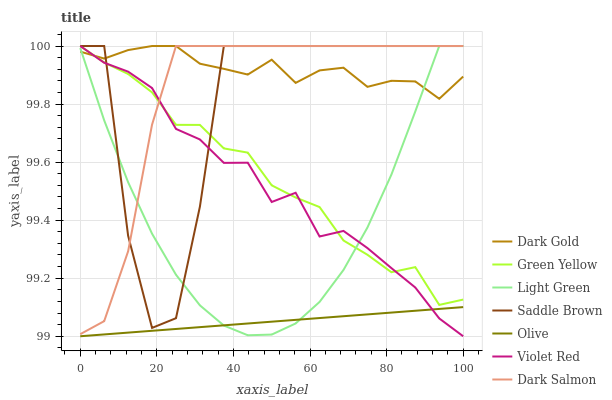Does Olive have the minimum area under the curve?
Answer yes or no. Yes. Does Dark Gold have the maximum area under the curve?
Answer yes or no. Yes. Does Dark Salmon have the minimum area under the curve?
Answer yes or no. No. Does Dark Salmon have the maximum area under the curve?
Answer yes or no. No. Is Olive the smoothest?
Answer yes or no. Yes. Is Saddle Brown the roughest?
Answer yes or no. Yes. Is Dark Gold the smoothest?
Answer yes or no. No. Is Dark Gold the roughest?
Answer yes or no. No. Does Violet Red have the lowest value?
Answer yes or no. Yes. Does Dark Salmon have the lowest value?
Answer yes or no. No. Does Saddle Brown have the highest value?
Answer yes or no. Yes. Does Olive have the highest value?
Answer yes or no. No. Is Olive less than Saddle Brown?
Answer yes or no. Yes. Is Saddle Brown greater than Olive?
Answer yes or no. Yes. Does Violet Red intersect Saddle Brown?
Answer yes or no. Yes. Is Violet Red less than Saddle Brown?
Answer yes or no. No. Is Violet Red greater than Saddle Brown?
Answer yes or no. No. Does Olive intersect Saddle Brown?
Answer yes or no. No. 